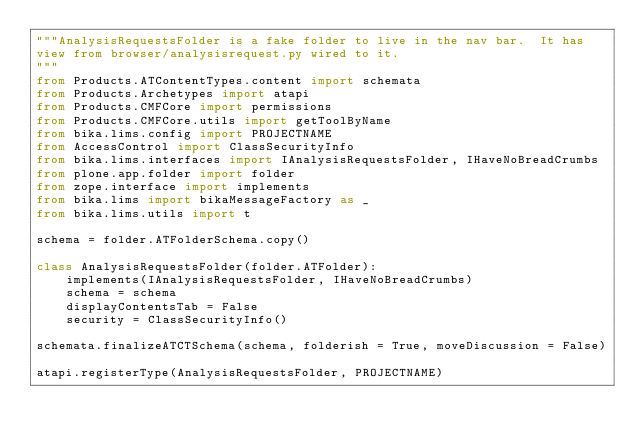Convert code to text. <code><loc_0><loc_0><loc_500><loc_500><_Python_>"""AnalysisRequestsFolder is a fake folder to live in the nav bar.  It has
view from browser/analysisrequest.py wired to it.
"""
from Products.ATContentTypes.content import schemata
from Products.Archetypes import atapi
from Products.CMFCore import permissions
from Products.CMFCore.utils import getToolByName
from bika.lims.config import PROJECTNAME
from AccessControl import ClassSecurityInfo
from bika.lims.interfaces import IAnalysisRequestsFolder, IHaveNoBreadCrumbs
from plone.app.folder import folder
from zope.interface import implements
from bika.lims import bikaMessageFactory as _
from bika.lims.utils import t

schema = folder.ATFolderSchema.copy()

class AnalysisRequestsFolder(folder.ATFolder):
    implements(IAnalysisRequestsFolder, IHaveNoBreadCrumbs)
    schema = schema
    displayContentsTab = False
    security = ClassSecurityInfo()

schemata.finalizeATCTSchema(schema, folderish = True, moveDiscussion = False)

atapi.registerType(AnalysisRequestsFolder, PROJECTNAME)
</code> 